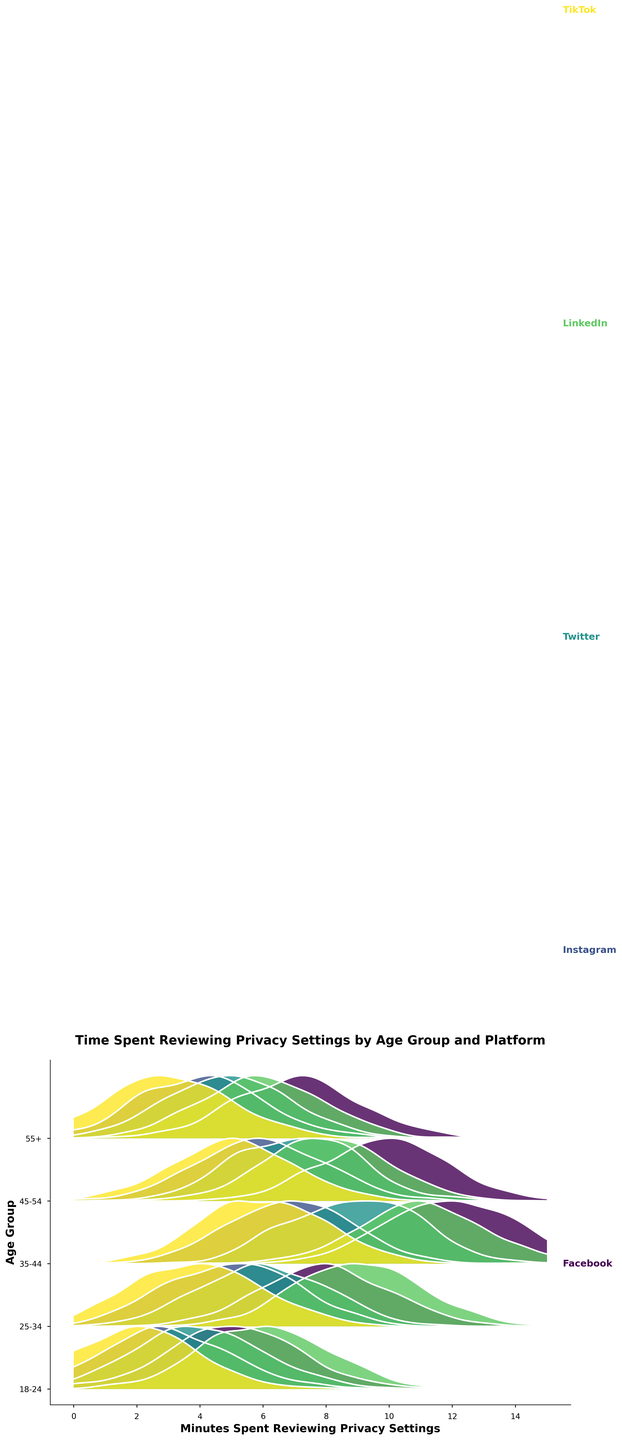What is the x-axis representing? The x-axis represents the minutes spent by users reviewing privacy settings on various social media platforms. It ranges from 0 to 15 minutes.
Answer: Minutes Spent Reviewing Privacy Settings Which platform shows the highest density of users spending 9 minutes reviewing privacy settings in the 35-44 age group? To find the highest density for the 35-44 age group at the 9-minute mark, we look at the ridge closest to 1 on the y-axis for each platform. Twitter's 35-44 age group has a prominent peak around 9 minutes.
Answer: Twitter How do the trends in time spent vary between the 18-24 age group and the 45-54 age group across platforms? By examining the ridgelines for both age groups across platforms, we can see notable differences. The 18-24 age group generally shows lower peaks and less time spent (1-6 minutes), while the 45-54 age group shows higher peaks and a wider range of time spent (5-12 minutes).
Answer: The 18-24 age group spends less time compared to the 45-54 age group Which age group on LinkedIn spends the most time reviewing privacy settings and what is the approximate peak density value? By analyzing the heights of the ridges for LinkedIn, the 35-44 age group shows the highest peak density. The approximate peak density value is 0.21.
Answer: 35-44; 0.21 Between Instagram and TikTok, which platform has a lower peak density for ages 25-34? By comparing the ridges for the 25-34 age group, TikTok shows a lower peak density than Instagram.
Answer: TikTok Which age group on Facebook has the widest range of time spent reviewing privacy settings? For Facebook, the widest range seems to occur in the 35-44 age group. We can observe multiple peaks spread over the x-axis from around 6 to 14 minutes.
Answer: 35-44 What is the pattern of time spent reviewing privacy settings for users aged 55+ on Twitter? The ridgeline for the 55+ age group on Twitter shows a single peak around 5 minutes, indicating that most users in this age group spend around that amount of time reviewing privacy settings.
Answer: A single peak around 5 minutes How does the density of users in the age group 45-54 on Instagram compare to those on LinkedIn? The ridgeline for 45-54 on Instagram shows a peak density lower than the ridge for the same age group on LinkedIn, indicating less concentrated review time on Instagram.
Answer: Lower on Instagram Which platform has the most consistent (narrow and high peak) time spent across all age groups? Facebook demonstrates consistent time spent across all age groups, evidenced by relatively narrow and high peaks in each ridgeline compared to other platforms.
Answer: Facebook 